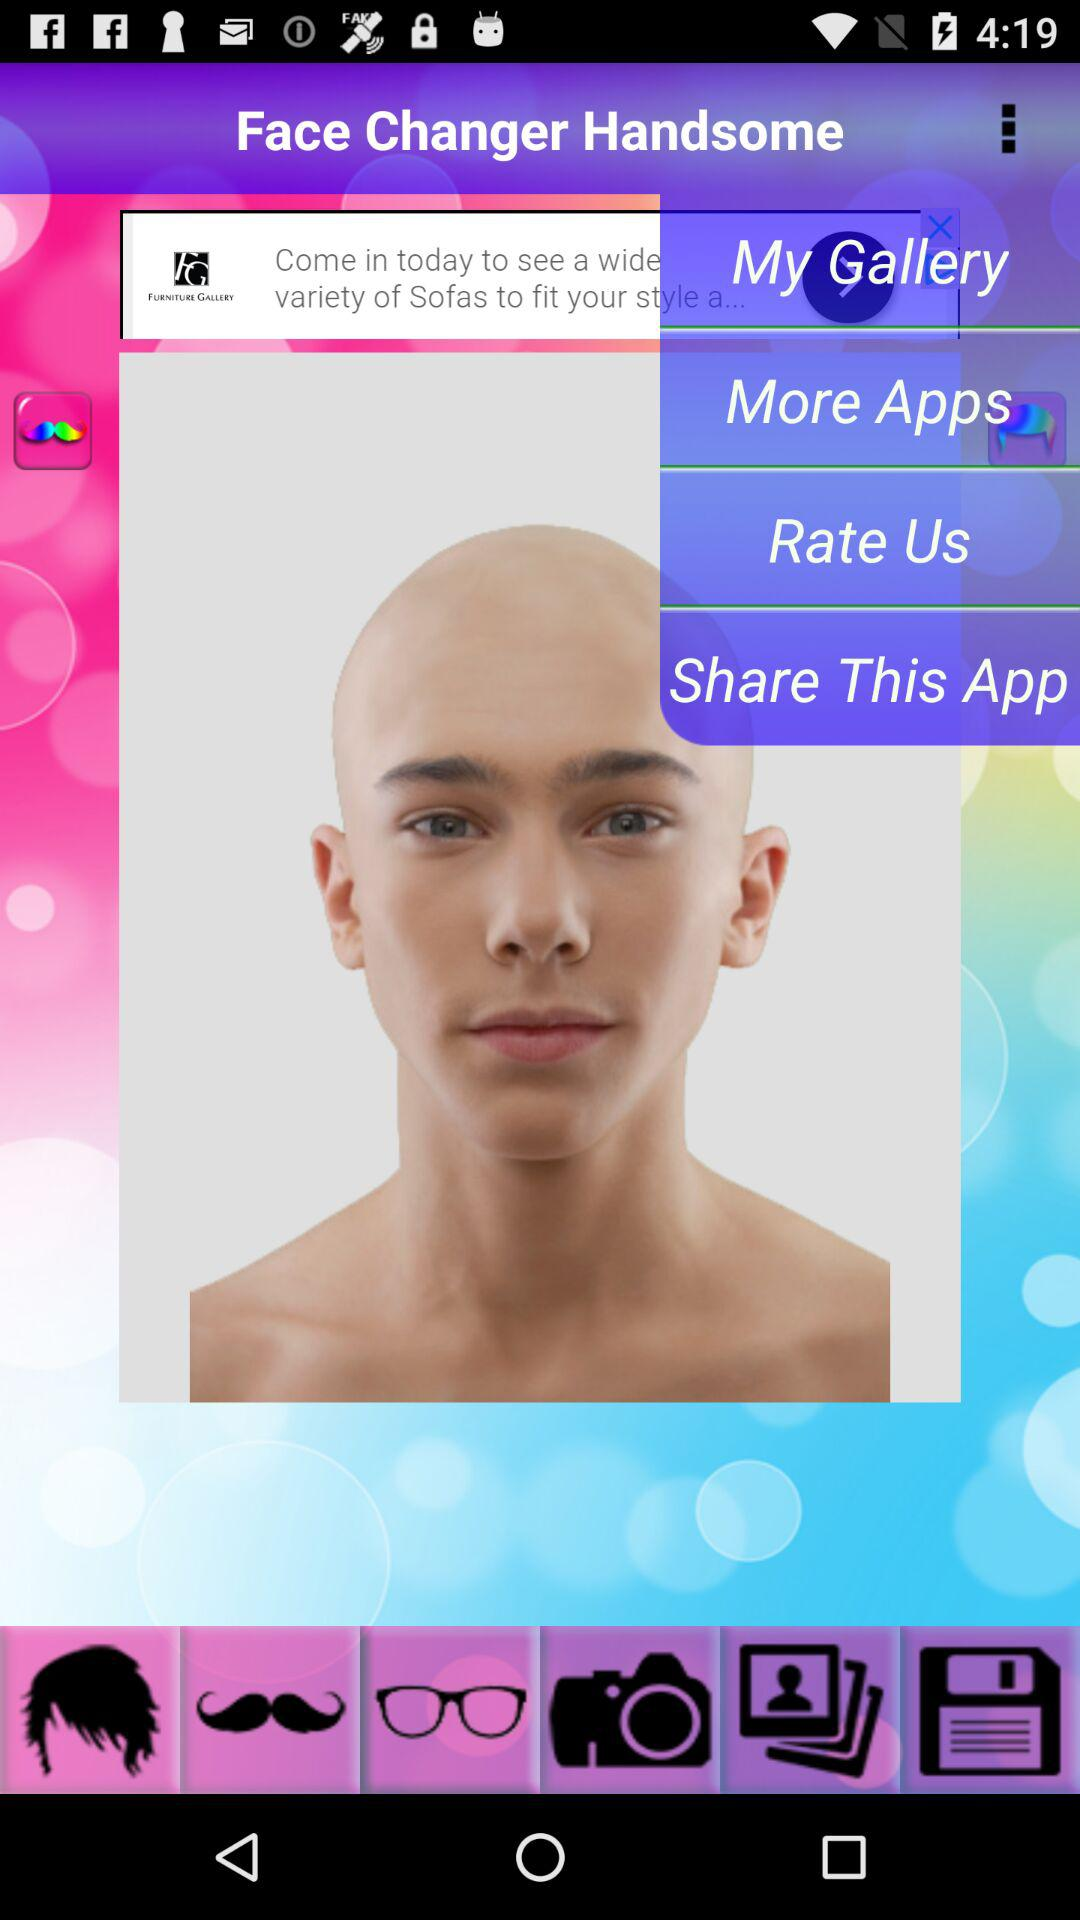What is the application name? The application name is "Face Changer Handsome". 